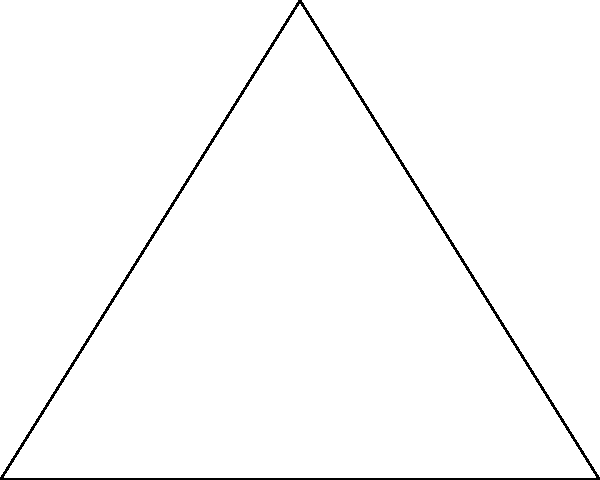Two ancient tribal settlements are located near a prominent landmark. From Settlement 1, the landmark is 5 km away and forms a 90° angle with the line connecting the two settlements. From Settlement 2, the landmark is 8 km away. Using this information, determine the distance between the two settlements. Let's approach this step-by-step using the Pythagorean theorem:

1) Let's define our triangle:
   - A: Settlement 1
   - B: Settlement 2
   - C: Landmark

2) We know:
   - AC = 5 km (distance from Settlement 1 to Landmark)
   - BC = 8 km (distance from Settlement 2 to Landmark)
   - Angle ACB is 90° (right angle)

3) We need to find AB (distance between settlements).

4) Using the Pythagorean theorem: $AB^2 = AC^2 + BC^2$

5) Substituting the known values:
   $AB^2 = 5^2 + 8^2$

6) Simplify:
   $AB^2 = 25 + 64 = 89$

7) Take the square root of both sides:
   $AB = \sqrt{89}$

8) Simplify:
   $AB \approx 9.43$ km

Therefore, the distance between the two settlements is approximately 9.43 km.
Answer: $\sqrt{89}$ km or approximately 9.43 km 